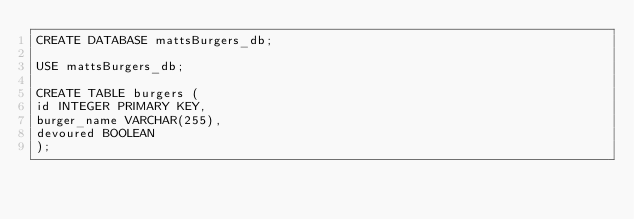<code> <loc_0><loc_0><loc_500><loc_500><_SQL_>CREATE DATABASE mattsBurgers_db;

USE mattsBurgers_db;

CREATE TABLE burgers (
id INTEGER PRIMARY KEY,
burger_name VARCHAR(255),
devoured BOOLEAN
);</code> 